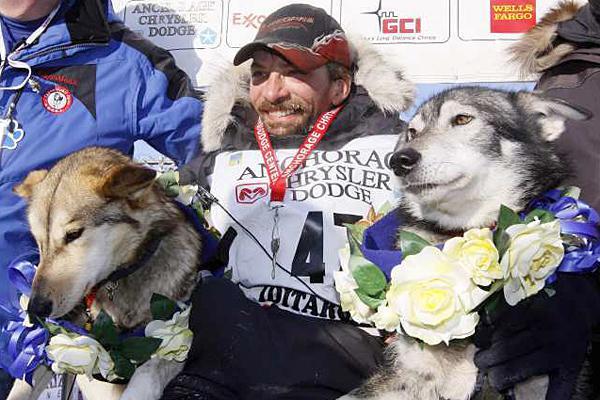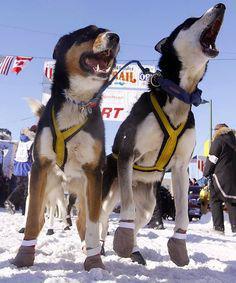The first image is the image on the left, the second image is the image on the right. Given the left and right images, does the statement "Both images in the pair show sled dogs attached to a sled." hold true? Answer yes or no. No. 